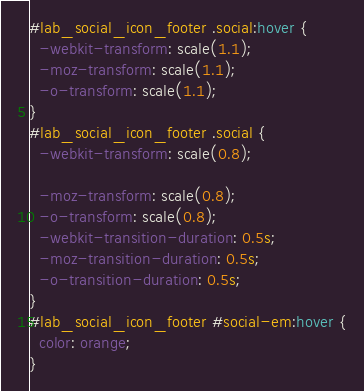<code> <loc_0><loc_0><loc_500><loc_500><_CSS_>#lab_social_icon_footer .social:hover {
  -webkit-transform: scale(1.1);
  -moz-transform: scale(1.1);
  -o-transform: scale(1.1);
}
#lab_social_icon_footer .social {
  -webkit-transform: scale(0.8);

  -moz-transform: scale(0.8);
  -o-transform: scale(0.8);
  -webkit-transition-duration: 0.5s;
  -moz-transition-duration: 0.5s;
  -o-transition-duration: 0.5s;
}
#lab_social_icon_footer #social-em:hover {
  color: orange;
}
</code> 